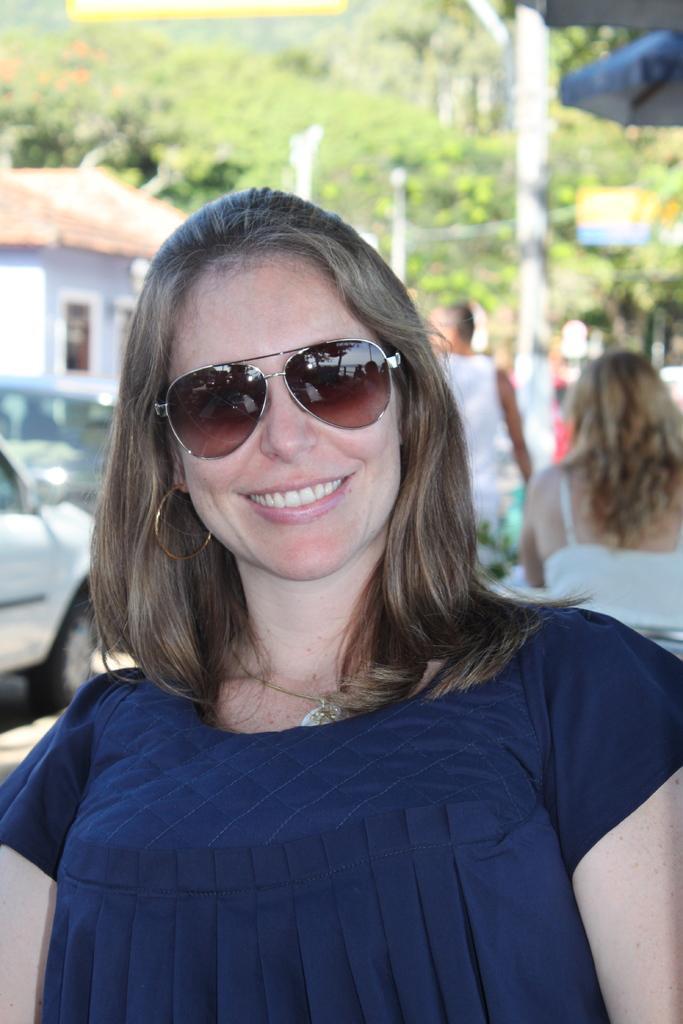Please provide a concise description of this image. In the picture there is a woman in the foreground, she is wearing goggles and smiling, behind the woman there are vehicles, house, trees and other people. 